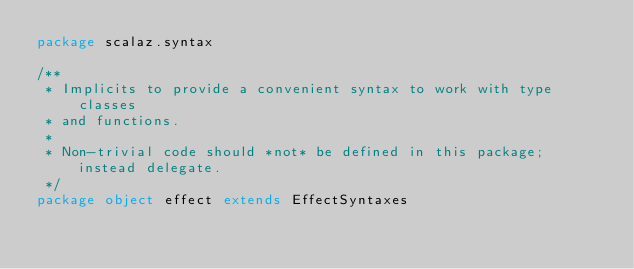Convert code to text. <code><loc_0><loc_0><loc_500><loc_500><_Scala_>package scalaz.syntax

/**
 * Implicits to provide a convenient syntax to work with type classes
 * and functions.
 *
 * Non-trivial code should *not* be defined in this package; instead delegate.
 */
package object effect extends EffectSyntaxes
</code> 